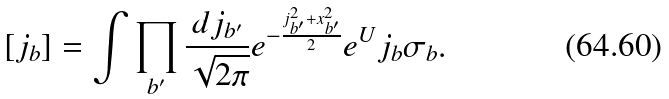<formula> <loc_0><loc_0><loc_500><loc_500>[ j _ { b } ] = \int \prod _ { b ^ { \prime } } \frac { d j _ { b ^ { \prime } } } { \sqrt { 2 \pi } } e ^ { - \frac { j _ { b ^ { \prime } } ^ { 2 } + x _ { b ^ { \prime } } ^ { 2 } } { 2 } } e ^ { U } j _ { b } \sigma _ { b } .</formula> 